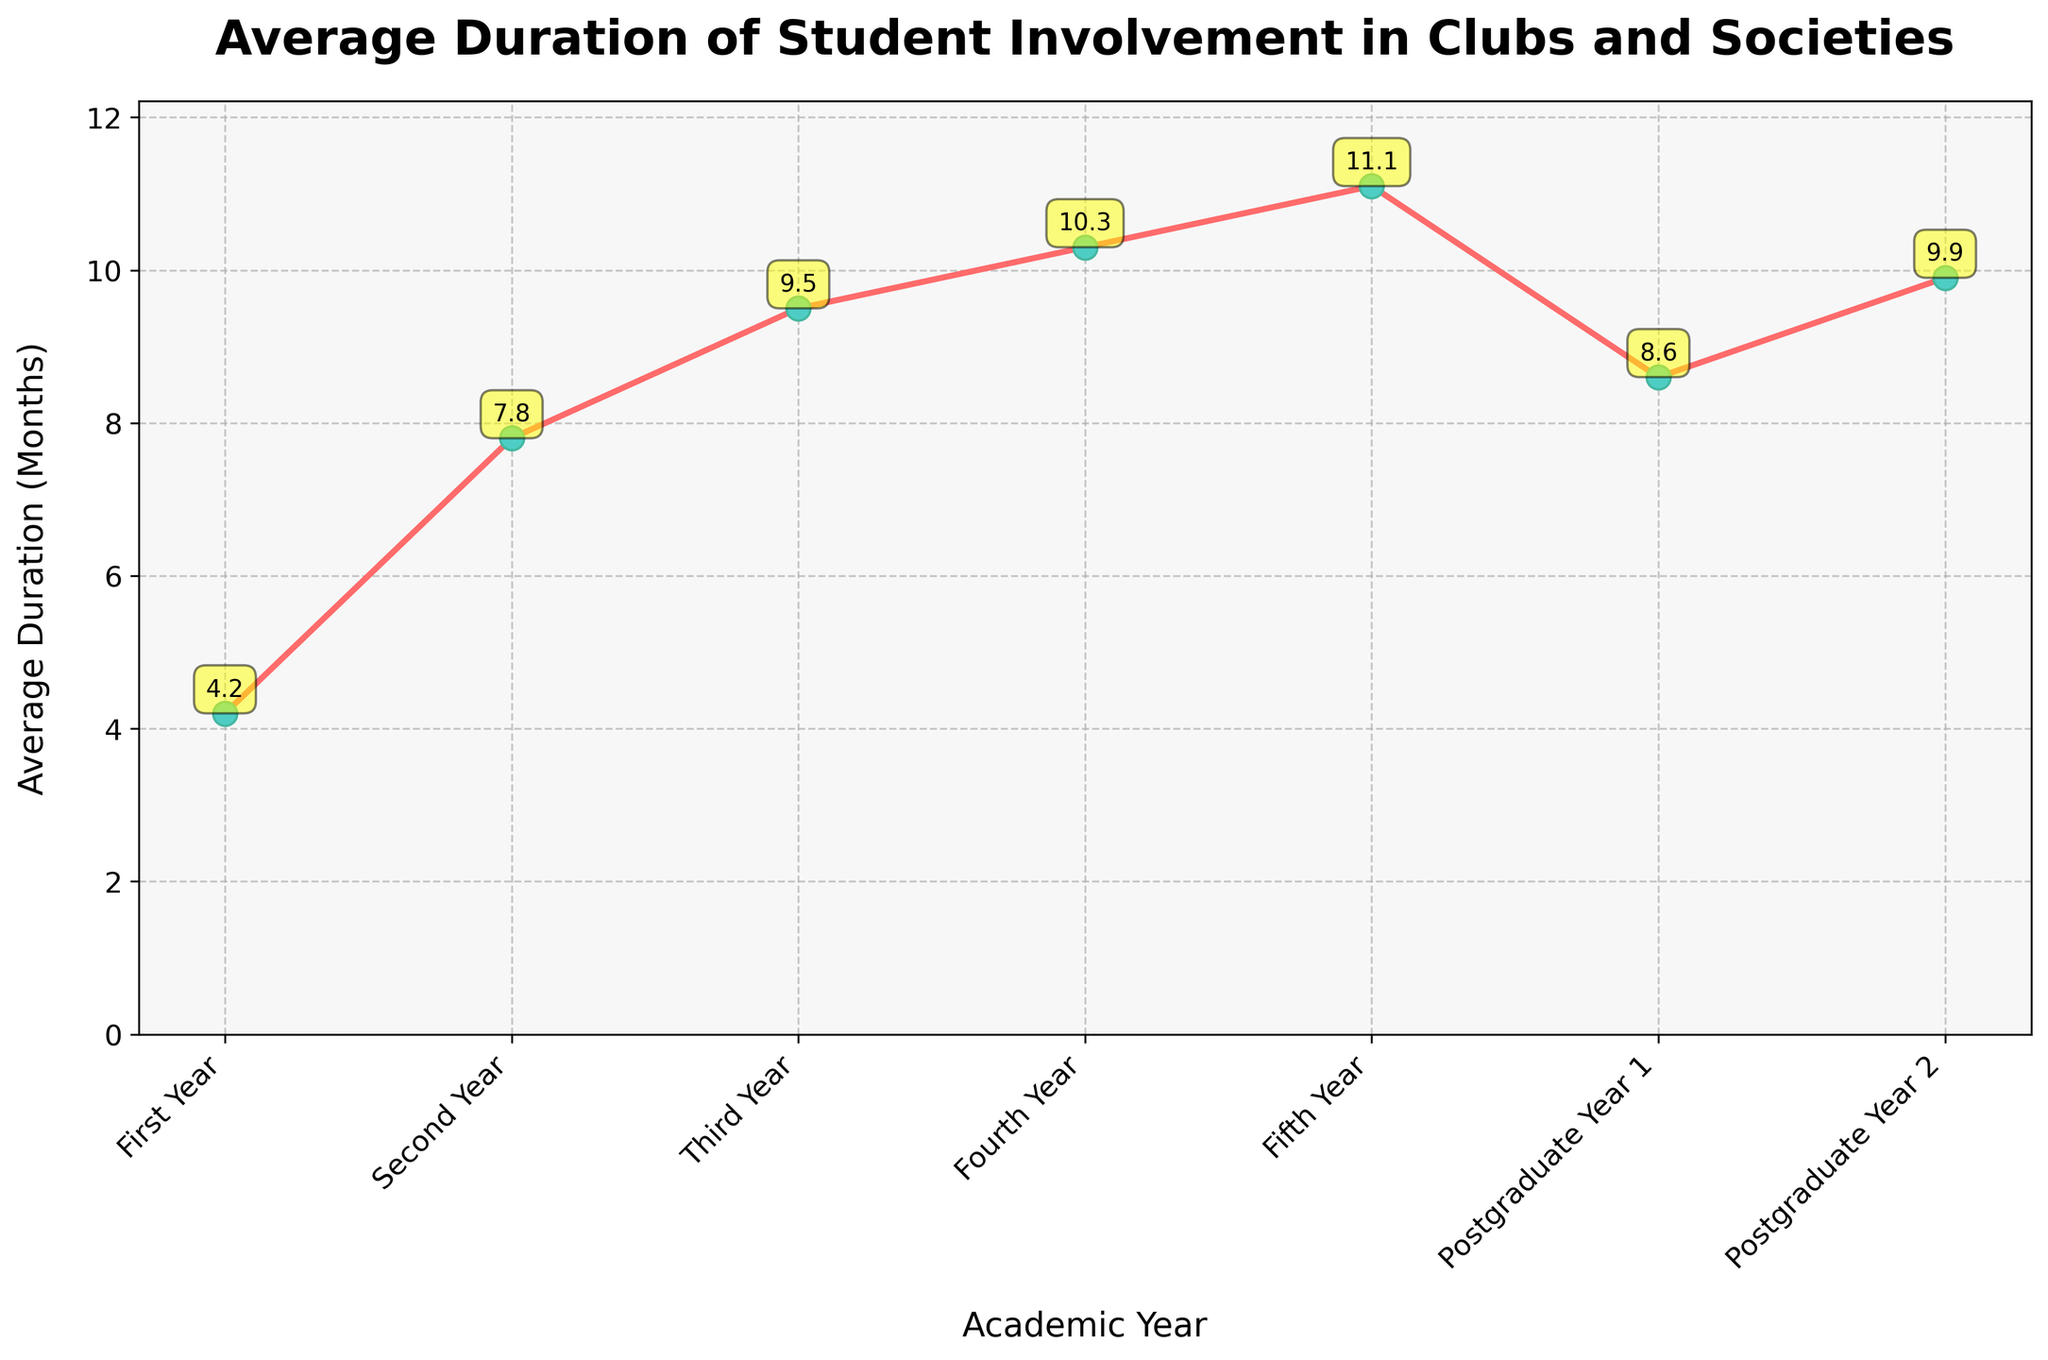What is the average duration of involvement in clubs and societies during the first year? The plot shows that the average duration of involvement in the first year is 4.2 months.
Answer: 4.2 months How does the average duration of involvement in clubs change from the first year to the fifth year? According to the plot, the average duration increases from 4.2 months in the first year to 11.1 months in the fifth year.
Answer: Increases by 6.9 months Compare the average duration of involvement between the third year and Postgraduate Year 2. The plot indicates that in the third year, the average duration is 9.5 months, while in Postgraduate Year 2, it is 9.9 months.
Answer: Postgraduate Year 2 is 0.4 months longer What is the total duration of involvement from the first year through the fourth year? Sum the average durations from the first year (4.2), second year (7.8), third year (9.5), and fourth year (10.3): 4.2 + 7.8 + 9.5 + 10.3 = 31.8 months.
Answer: 31.8 months Does the average duration of involvement decrease in any year? By examining the plot, the average duration decreases from 11.1 months in the fifth year to 8.6 months in the first postgraduate year but then increases again.
Answer: Yes, from the fifth year to the first postgraduate year Which academic year has the highest average duration of involvement in clubs? The plot shows that the fifth year has the highest average duration of 11.1 months.
Answer: Fifth year How does the average duration of involvement in clubs in Postgraduate Year 1 compare to that in the second year? The plot indicates that the average duration in Postgraduate Year 1 is 8.6 months, while in the second year, it is 7.8 months.
Answer: Postgraduate Year 1 is 0.8 months longer What is the difference in average duration between the second year and the fourth year? According to the plot, the second year duration is 7.8 months and the fourth year duration is 10.3 months. The difference is 10.3 - 7.8 = 2.5 months.
Answer: 2.5 months What trend can be observed in the average duration of involvement over the academic years? The plot shows that the average duration of involvement generally increases each year, with a dip between the fifth year and the first postgraduate year before rising again in the second postgraduate year.
Answer: Generally increasing with a dip between the fifth year and the first postgraduate year 